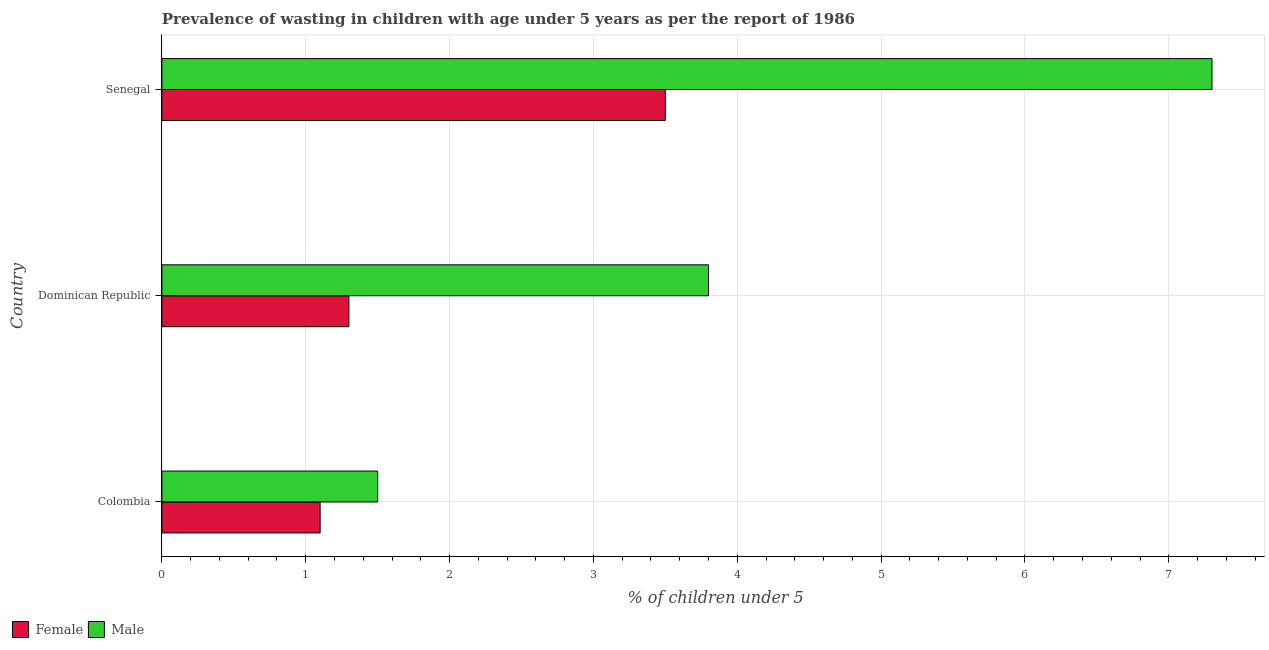Are the number of bars per tick equal to the number of legend labels?
Provide a succinct answer. Yes. Are the number of bars on each tick of the Y-axis equal?
Provide a succinct answer. Yes. How many bars are there on the 3rd tick from the top?
Provide a succinct answer. 2. How many bars are there on the 1st tick from the bottom?
Give a very brief answer. 2. What is the label of the 2nd group of bars from the top?
Your answer should be very brief. Dominican Republic. In how many cases, is the number of bars for a given country not equal to the number of legend labels?
Offer a terse response. 0. What is the percentage of undernourished female children in Senegal?
Provide a short and direct response. 3.5. Across all countries, what is the maximum percentage of undernourished male children?
Provide a short and direct response. 7.3. Across all countries, what is the minimum percentage of undernourished female children?
Provide a succinct answer. 1.1. In which country was the percentage of undernourished female children maximum?
Provide a succinct answer. Senegal. In which country was the percentage of undernourished female children minimum?
Provide a short and direct response. Colombia. What is the total percentage of undernourished female children in the graph?
Keep it short and to the point. 5.9. What is the difference between the percentage of undernourished male children in Dominican Republic and the percentage of undernourished female children in Senegal?
Give a very brief answer. 0.3. What is the ratio of the percentage of undernourished male children in Colombia to that in Senegal?
Make the answer very short. 0.2. What is the difference between the highest and the second highest percentage of undernourished female children?
Make the answer very short. 2.2. What is the difference between the highest and the lowest percentage of undernourished female children?
Your answer should be compact. 2.4. In how many countries, is the percentage of undernourished male children greater than the average percentage of undernourished male children taken over all countries?
Give a very brief answer. 1. Is the sum of the percentage of undernourished male children in Colombia and Senegal greater than the maximum percentage of undernourished female children across all countries?
Provide a short and direct response. Yes. What does the 2nd bar from the top in Senegal represents?
Make the answer very short. Female. How many bars are there?
Provide a short and direct response. 6. How many countries are there in the graph?
Ensure brevity in your answer.  3. Does the graph contain any zero values?
Give a very brief answer. No. How many legend labels are there?
Ensure brevity in your answer.  2. How are the legend labels stacked?
Keep it short and to the point. Horizontal. What is the title of the graph?
Make the answer very short. Prevalence of wasting in children with age under 5 years as per the report of 1986. Does "Imports" appear as one of the legend labels in the graph?
Your answer should be very brief. No. What is the label or title of the X-axis?
Offer a very short reply.  % of children under 5. What is the label or title of the Y-axis?
Your answer should be compact. Country. What is the  % of children under 5 of Female in Colombia?
Provide a succinct answer. 1.1. What is the  % of children under 5 in Male in Colombia?
Provide a succinct answer. 1.5. What is the  % of children under 5 in Female in Dominican Republic?
Your answer should be very brief. 1.3. What is the  % of children under 5 of Male in Dominican Republic?
Your answer should be compact. 3.8. What is the  % of children under 5 of Female in Senegal?
Ensure brevity in your answer.  3.5. What is the  % of children under 5 of Male in Senegal?
Ensure brevity in your answer.  7.3. Across all countries, what is the maximum  % of children under 5 in Male?
Offer a terse response. 7.3. Across all countries, what is the minimum  % of children under 5 of Female?
Offer a very short reply. 1.1. What is the total  % of children under 5 of Female in the graph?
Your answer should be very brief. 5.9. What is the difference between the  % of children under 5 in Male in Colombia and that in Senegal?
Provide a succinct answer. -5.8. What is the difference between the  % of children under 5 in Male in Dominican Republic and that in Senegal?
Provide a short and direct response. -3.5. What is the difference between the  % of children under 5 of Female in Colombia and the  % of children under 5 of Male in Dominican Republic?
Your answer should be compact. -2.7. What is the difference between the  % of children under 5 of Female in Dominican Republic and the  % of children under 5 of Male in Senegal?
Ensure brevity in your answer.  -6. What is the average  % of children under 5 in Female per country?
Make the answer very short. 1.97. What is the ratio of the  % of children under 5 in Female in Colombia to that in Dominican Republic?
Provide a short and direct response. 0.85. What is the ratio of the  % of children under 5 in Male in Colombia to that in Dominican Republic?
Offer a terse response. 0.39. What is the ratio of the  % of children under 5 of Female in Colombia to that in Senegal?
Offer a very short reply. 0.31. What is the ratio of the  % of children under 5 of Male in Colombia to that in Senegal?
Your answer should be very brief. 0.21. What is the ratio of the  % of children under 5 of Female in Dominican Republic to that in Senegal?
Provide a short and direct response. 0.37. What is the ratio of the  % of children under 5 in Male in Dominican Republic to that in Senegal?
Offer a very short reply. 0.52. What is the difference between the highest and the second highest  % of children under 5 in Male?
Keep it short and to the point. 3.5. What is the difference between the highest and the lowest  % of children under 5 of Female?
Your response must be concise. 2.4. What is the difference between the highest and the lowest  % of children under 5 of Male?
Offer a terse response. 5.8. 